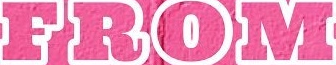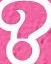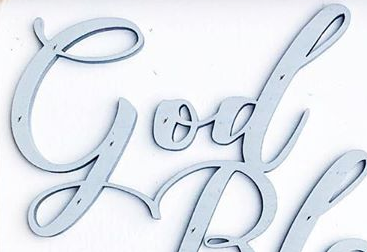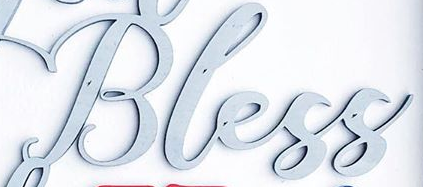Identify the words shown in these images in order, separated by a semicolon. FROM; ?; God; Bless 